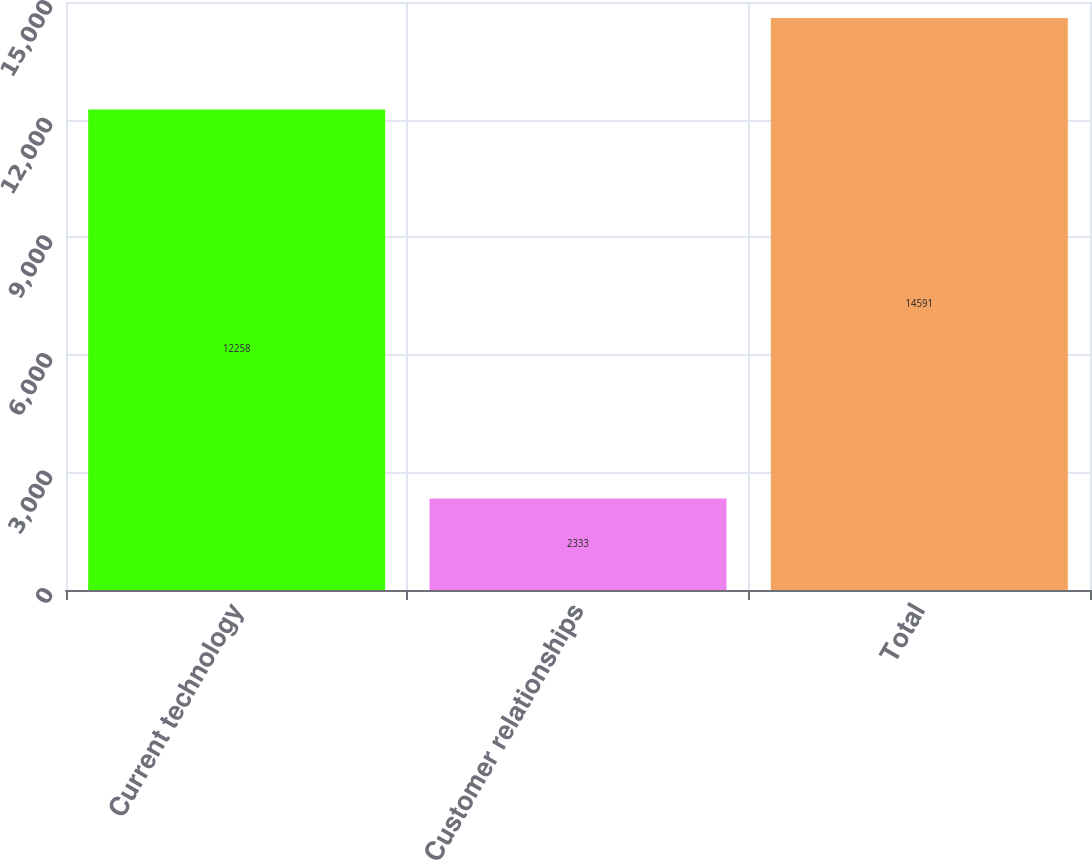Convert chart to OTSL. <chart><loc_0><loc_0><loc_500><loc_500><bar_chart><fcel>Current technology<fcel>Customer relationships<fcel>Total<nl><fcel>12258<fcel>2333<fcel>14591<nl></chart> 